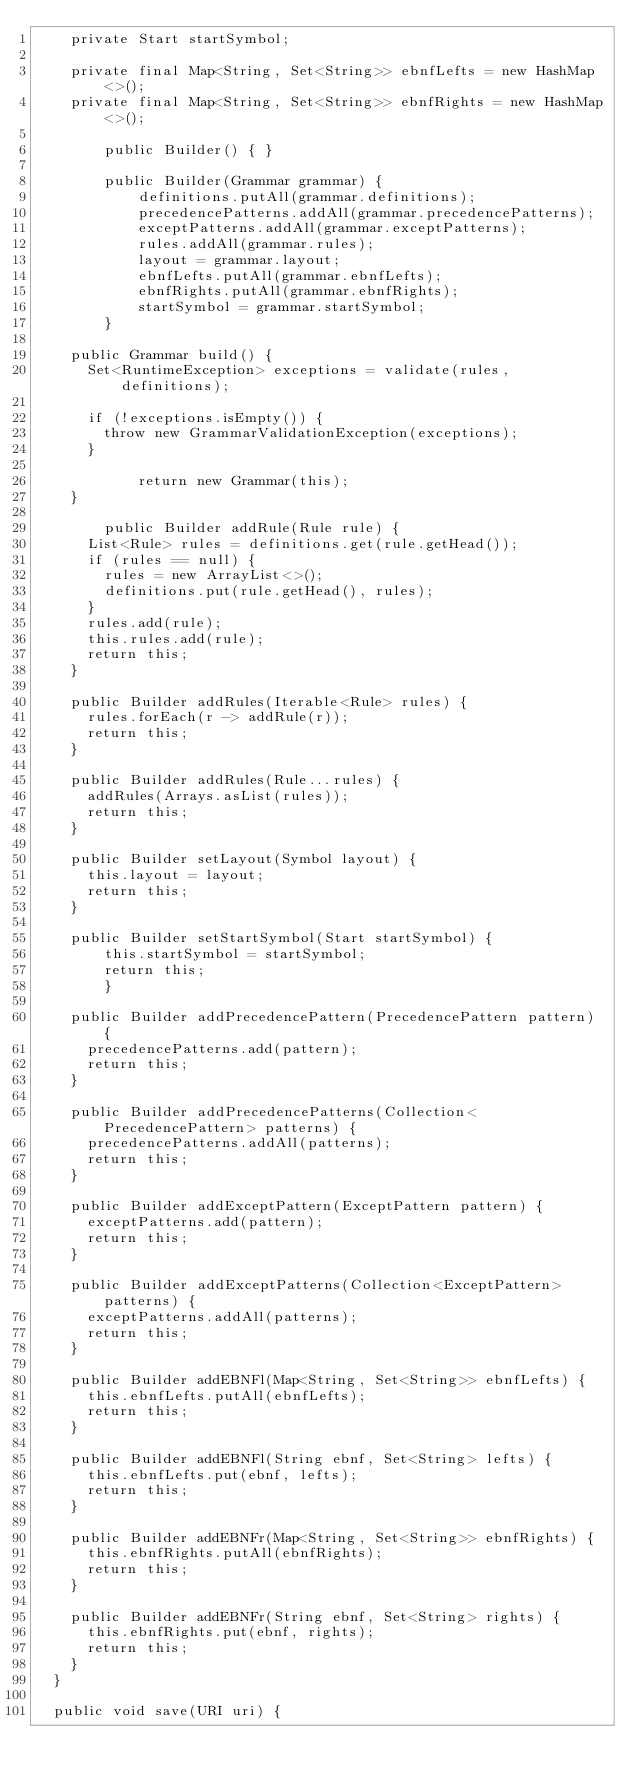<code> <loc_0><loc_0><loc_500><loc_500><_Java_>		private Start startSymbol;
		
		private final Map<String, Set<String>> ebnfLefts = new HashMap<>();
		private final Map<String, Set<String>> ebnfRights = new HashMap<>();

        public Builder() { }

        public Builder(Grammar grammar) {
            definitions.putAll(grammar.definitions);
            precedencePatterns.addAll(grammar.precedencePatterns);
            exceptPatterns.addAll(grammar.exceptPatterns);
            rules.addAll(grammar.rules);
            layout = grammar.layout;
            ebnfLefts.putAll(grammar.ebnfLefts);
            ebnfRights.putAll(grammar.ebnfRights);
            startSymbol = grammar.startSymbol;
        }
		
		public Grammar build() {
			Set<RuntimeException> exceptions = validate(rules, definitions);
			
			if (!exceptions.isEmpty()) {
				throw new GrammarValidationException(exceptions);
			}

            return new Grammar(this);
		}

        public Builder addRule(Rule rule) {
			List<Rule> rules = definitions.get(rule.getHead());
			if (rules == null) {
				rules = new ArrayList<>();
				definitions.put(rule.getHead(), rules);
			}
			rules.add(rule);
			this.rules.add(rule);
			return this;
		}
		
		public Builder addRules(Iterable<Rule> rules) {
			rules.forEach(r -> addRule(r));
			return this;
		}
		
		public Builder addRules(Rule...rules) {
			addRules(Arrays.asList(rules));
			return this;
		}
		
		public Builder setLayout(Symbol layout) {
			this.layout = layout;
			return this;
		}

		public Builder setStartSymbol(Start startSymbol) {
		    this.startSymbol = startSymbol;
		    return this;
        }
		
		public Builder addPrecedencePattern(PrecedencePattern pattern) {
			precedencePatterns.add(pattern);
			return this;
		}
		
		public Builder addPrecedencePatterns(Collection<PrecedencePattern> patterns) {
			precedencePatterns.addAll(patterns);
			return this;
		}		
		
		public Builder addExceptPattern(ExceptPattern pattern) {
			exceptPatterns.add(pattern);
			return this;
		}
		
		public Builder addExceptPatterns(Collection<ExceptPattern> patterns) {
			exceptPatterns.addAll(patterns);
			return this;
		}
		
		public Builder addEBNFl(Map<String, Set<String>> ebnfLefts) {
			this.ebnfLefts.putAll(ebnfLefts);
			return this;
		}
		
		public Builder addEBNFl(String ebnf, Set<String> lefts) {
			this.ebnfLefts.put(ebnf, lefts);
			return this;
		}
		
		public Builder addEBNFr(Map<String, Set<String>> ebnfRights) {
			this.ebnfRights.putAll(ebnfRights);
			return this;
		}
		
		public Builder addEBNFr(String ebnf, Set<String> rights) {
			this.ebnfRights.put(ebnf, rights);
			return this;
		}
	}

	public void save(URI uri) {</code> 